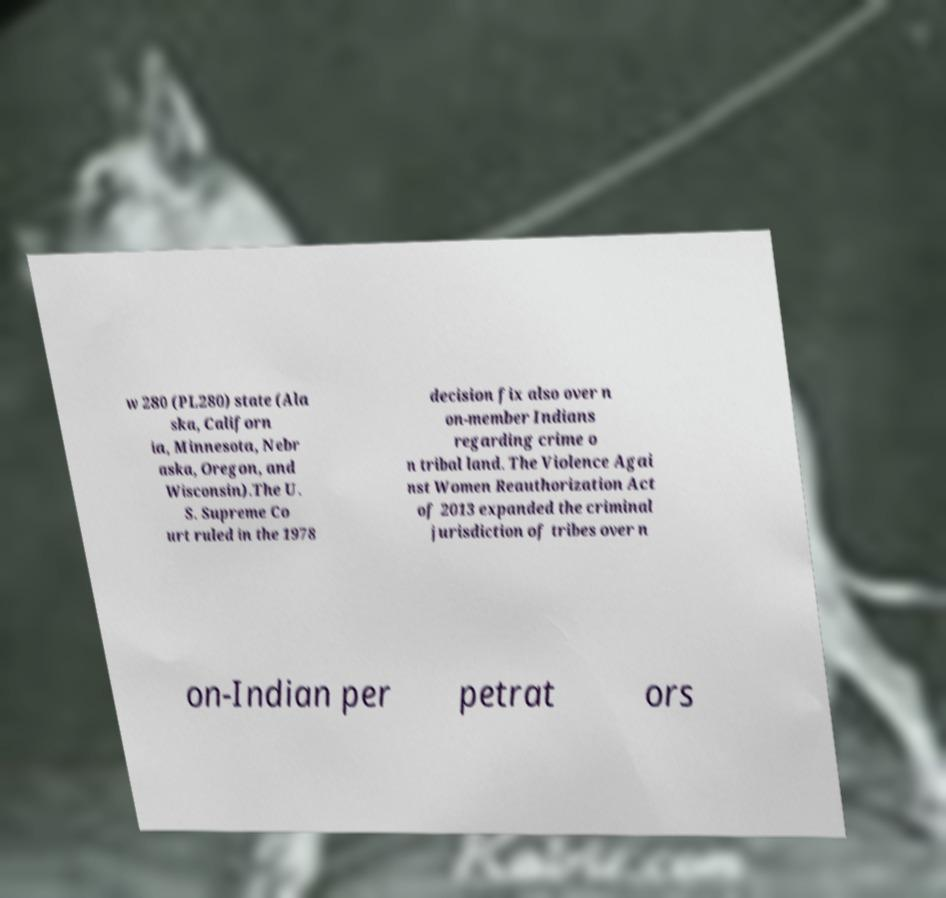What messages or text are displayed in this image? I need them in a readable, typed format. w 280 (PL280) state (Ala ska, Californ ia, Minnesota, Nebr aska, Oregon, and Wisconsin).The U. S. Supreme Co urt ruled in the 1978 decision fix also over n on-member Indians regarding crime o n tribal land. The Violence Agai nst Women Reauthorization Act of 2013 expanded the criminal jurisdiction of tribes over n on-Indian per petrat ors 